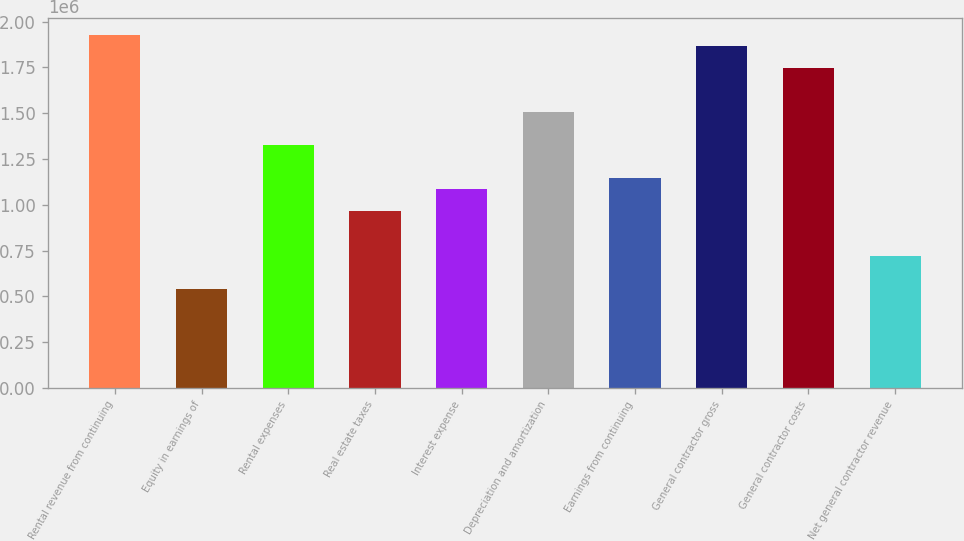Convert chart. <chart><loc_0><loc_0><loc_500><loc_500><bar_chart><fcel>Rental revenue from continuing<fcel>Equity in earnings of<fcel>Rental expenses<fcel>Real estate taxes<fcel>Interest expense<fcel>Depreciation and amortization<fcel>Earnings from continuing<fcel>General contractor gross<fcel>General contractor costs<fcel>Net general contractor revenue<nl><fcel>1.9266e+06<fcel>541856<fcel>1.32454e+06<fcel>963299<fcel>1.08371e+06<fcel>1.50515e+06<fcel>1.14392e+06<fcel>1.86639e+06<fcel>1.74598e+06<fcel>722474<nl></chart> 